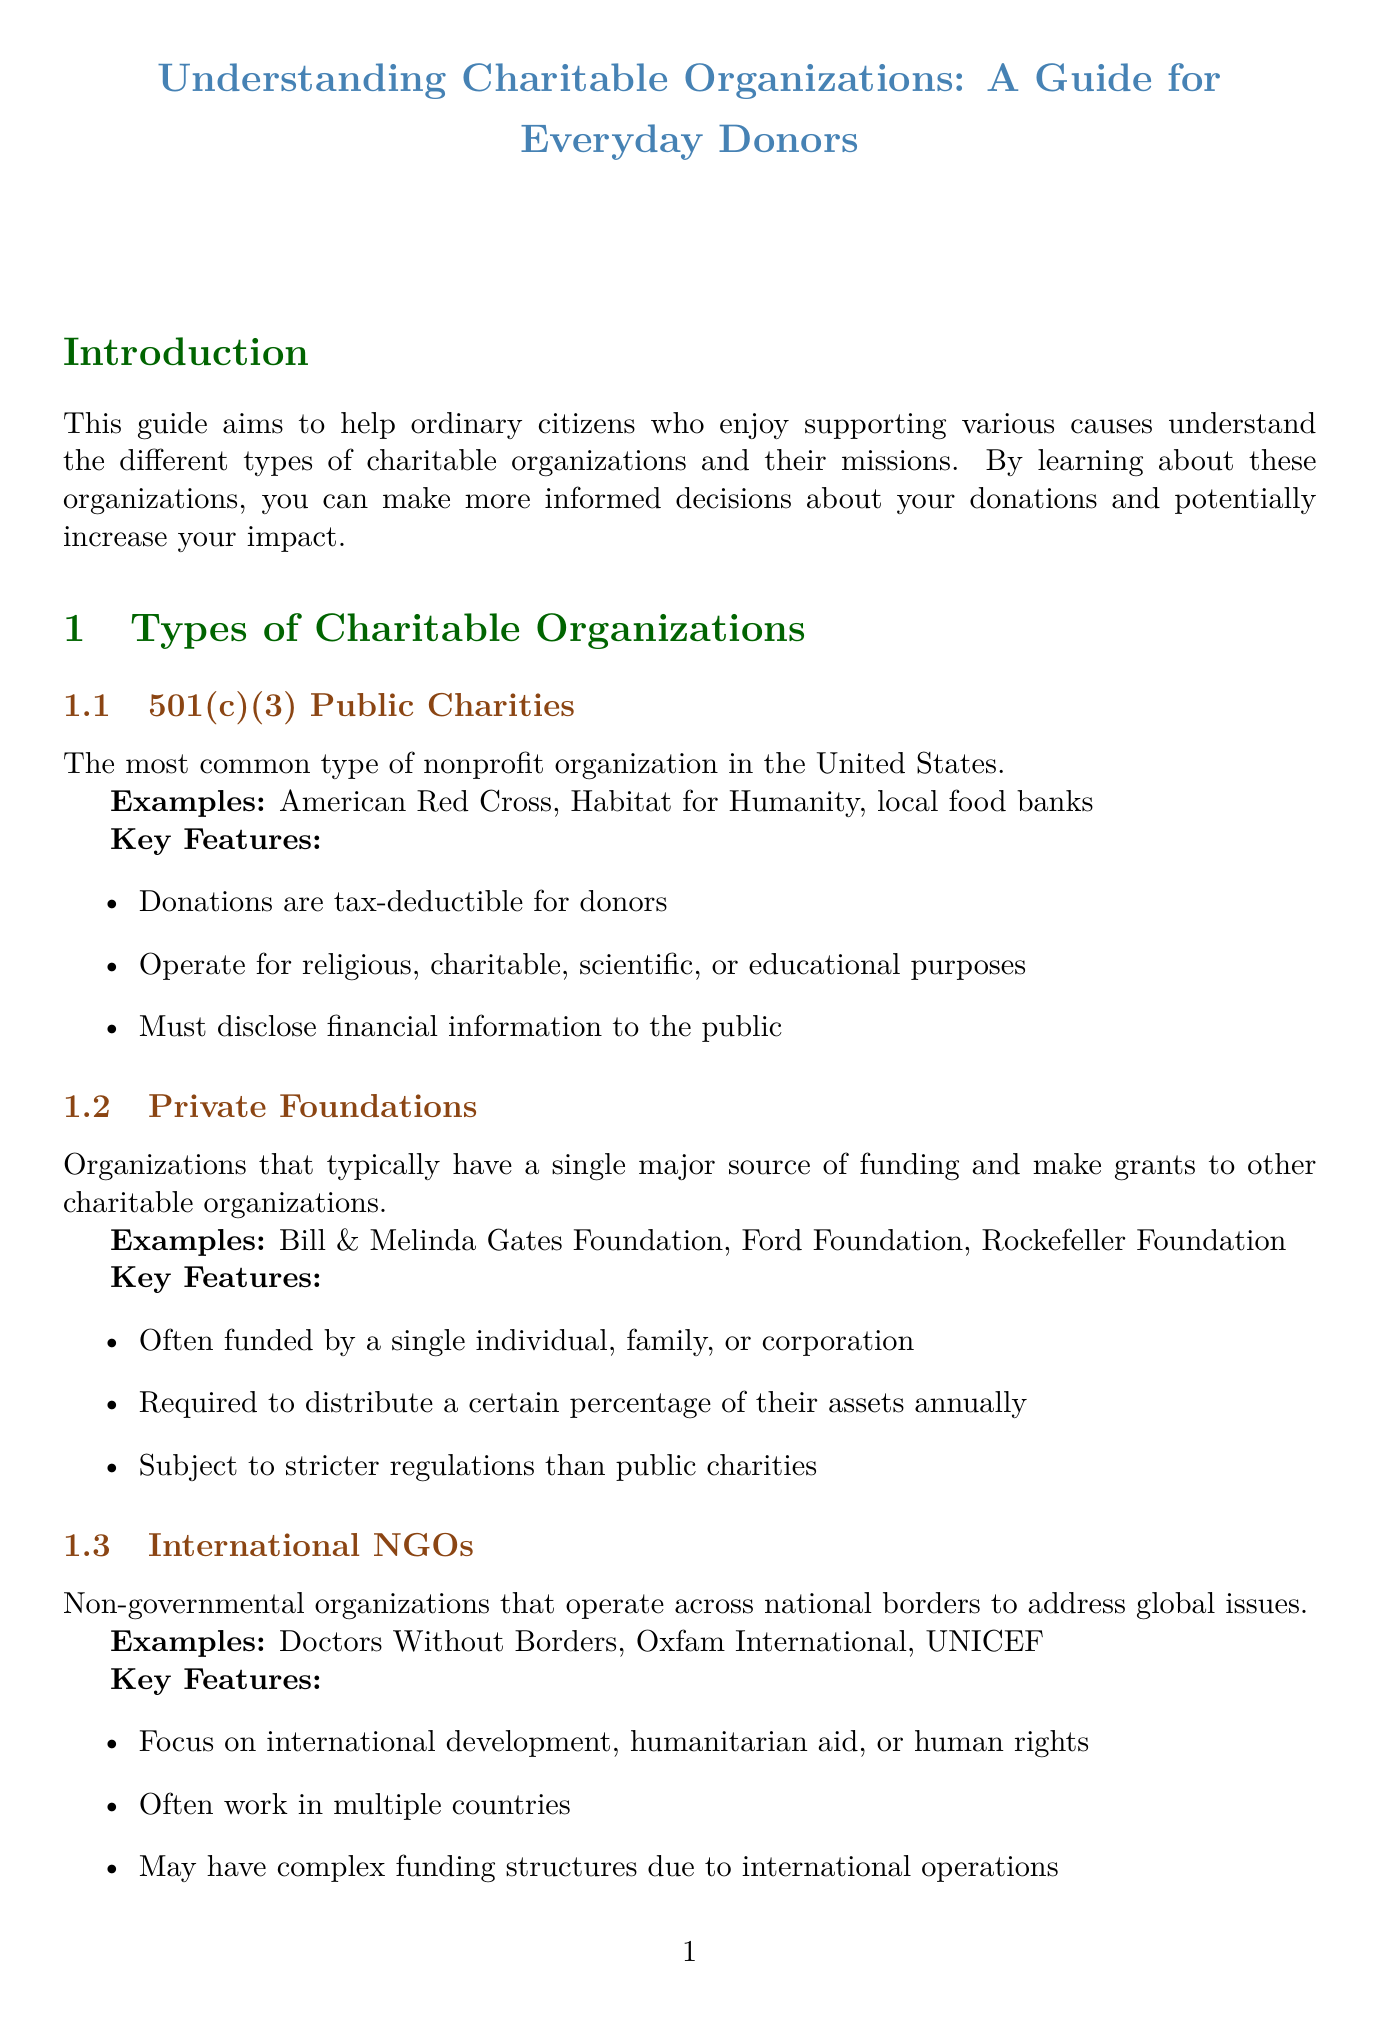what is the title of the guide? The title of the guide is found in the introduction section, which clearly states the purpose of the document.
Answer: Understanding Charitable Organizations: A Guide for Everyday Donors how many types of charitable organizations are mentioned? The document lists three types of charitable organizations under the relevant section.
Answer: three give an example of a Private Foundation The examples for Private Foundations are provided in a list format.
Answer: Bill & Melinda Gates Foundation what is the mission related to access to education? The document organizes missions and provides details, including the educational mission.
Answer: Education name an organization focused on Healthcare The examples are given under the Healthcare mission section.
Answer: St. Jude Children's Research Hospital which website can be used to research organizations before donating? The tips for everyday donors include specific resources for researching organizations.
Answer: Charity Navigator what is one key feature of 501(c)(3) Public Charities? The key features are listed concisely in the respective section, highlighting their primary characteristics.
Answer: Donations are tax-deductible for donors how can donors see the direct impact of their contributions? The document addresses this in the tips section by suggesting engagement in local charity work.
Answer: Consider local impact 